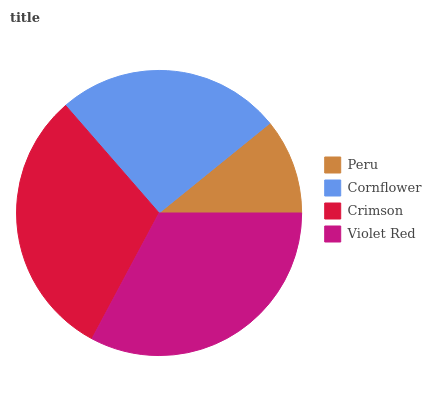Is Peru the minimum?
Answer yes or no. Yes. Is Violet Red the maximum?
Answer yes or no. Yes. Is Cornflower the minimum?
Answer yes or no. No. Is Cornflower the maximum?
Answer yes or no. No. Is Cornflower greater than Peru?
Answer yes or no. Yes. Is Peru less than Cornflower?
Answer yes or no. Yes. Is Peru greater than Cornflower?
Answer yes or no. No. Is Cornflower less than Peru?
Answer yes or no. No. Is Crimson the high median?
Answer yes or no. Yes. Is Cornflower the low median?
Answer yes or no. Yes. Is Peru the high median?
Answer yes or no. No. Is Peru the low median?
Answer yes or no. No. 